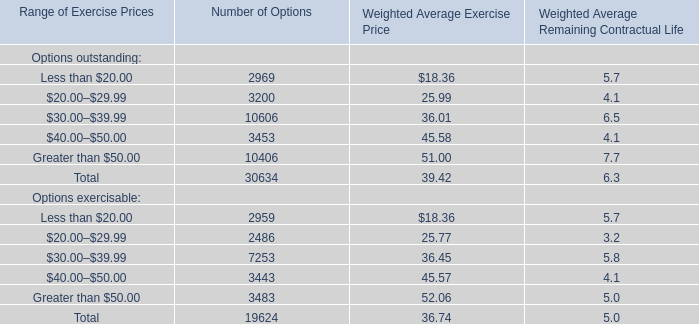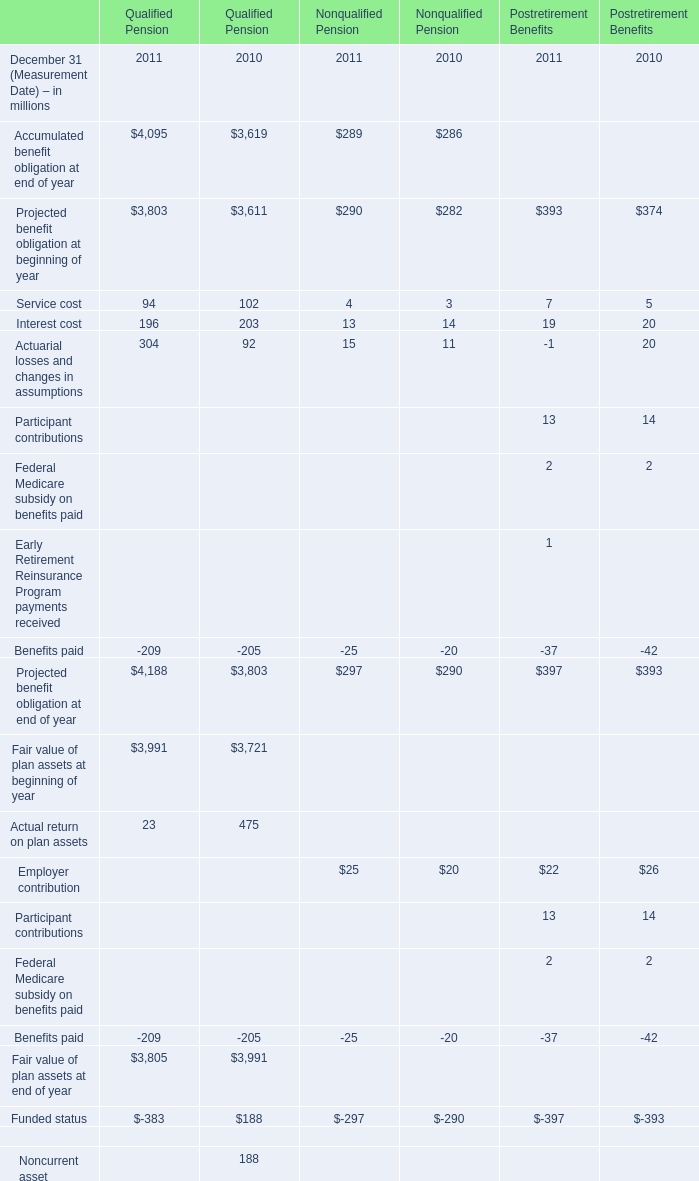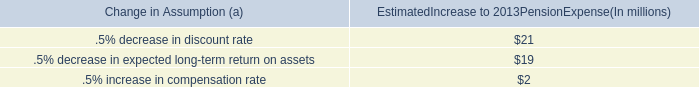What was the total amount of Service cost, interest cost,Actuarial losses and changes in assumptions and Projected benefit obligation at beginning of year in 2010 for nonqualified pension? (in million) 
Computations: (((3 + 14) + 11) + 282)
Answer: 310.0. 